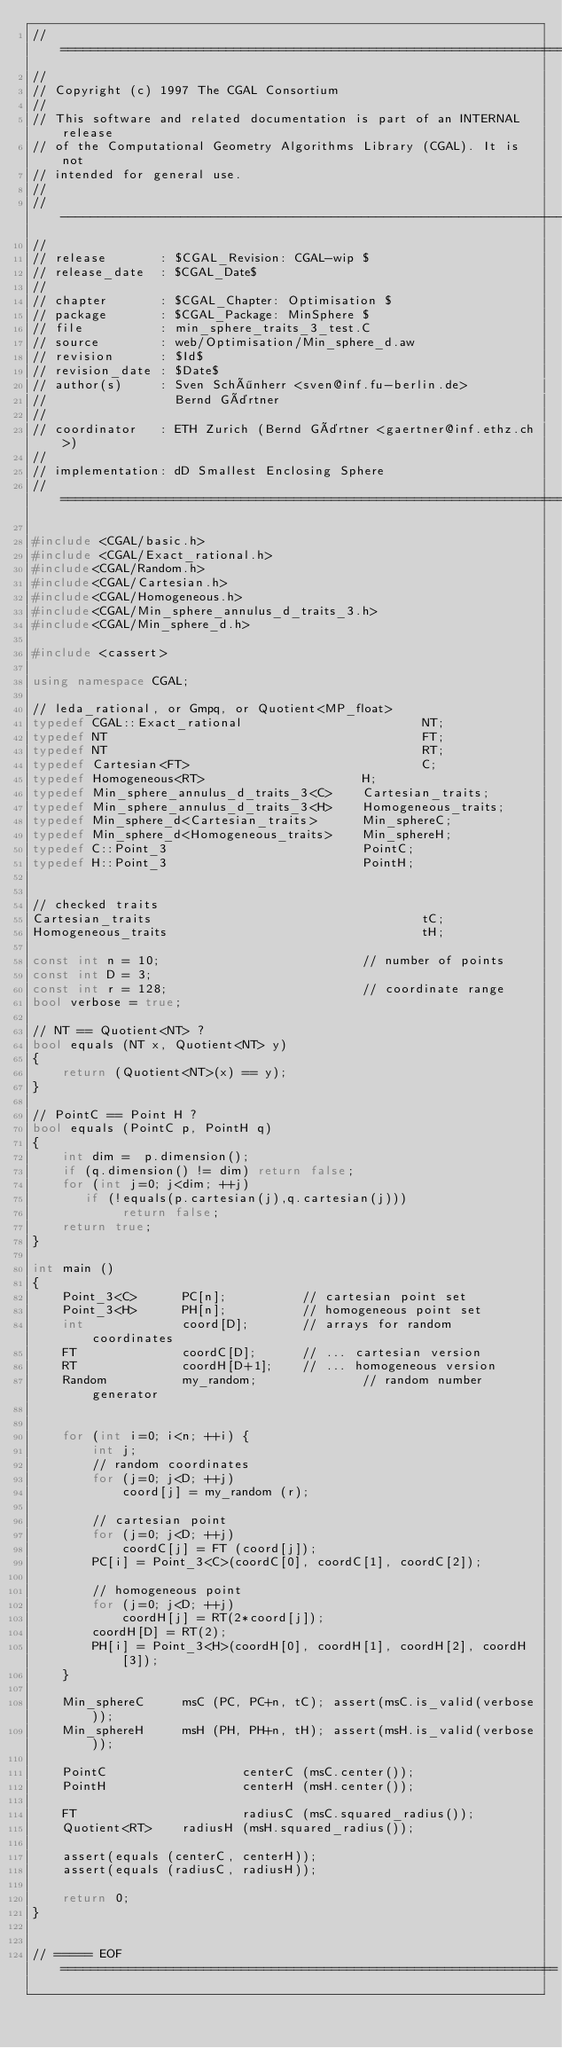Convert code to text. <code><loc_0><loc_0><loc_500><loc_500><_C++_>// ============================================================================
//
// Copyright (c) 1997 The CGAL Consortium
//
// This software and related documentation is part of an INTERNAL release
// of the Computational Geometry Algorithms Library (CGAL). It is not
// intended for general use.
//
// ----------------------------------------------------------------------------
//
// release       : $CGAL_Revision: CGAL-wip $
// release_date  : $CGAL_Date$
//
// chapter       : $CGAL_Chapter: Optimisation $
// package       : $CGAL_Package: MinSphere $
// file          : min_sphere_traits_3_test.C
// source        : web/Optimisation/Min_sphere_d.aw
// revision      : $Id$
// revision_date : $Date$
// author(s)     : Sven Schönherr <sven@inf.fu-berlin.de>
//                 Bernd Gärtner
//
// coordinator   : ETH Zurich (Bernd Gärtner <gaertner@inf.ethz.ch>)
//
// implementation: dD Smallest Enclosing Sphere
// ============================================================================

#include <CGAL/basic.h>
#include <CGAL/Exact_rational.h>
#include<CGAL/Random.h>
#include<CGAL/Cartesian.h>
#include<CGAL/Homogeneous.h>
#include<CGAL/Min_sphere_annulus_d_traits_3.h>
#include<CGAL/Min_sphere_d.h>

#include <cassert>

using namespace CGAL;

// leda_rational, or Gmpq, or Quotient<MP_float>
typedef CGAL::Exact_rational                        NT;
typedef NT                                          FT;
typedef NT                                          RT;
typedef Cartesian<FT>                               C;
typedef Homogeneous<RT>                     H;
typedef Min_sphere_annulus_d_traits_3<C>    Cartesian_traits;
typedef Min_sphere_annulus_d_traits_3<H>    Homogeneous_traits;
typedef Min_sphere_d<Cartesian_traits>      Min_sphereC;
typedef Min_sphere_d<Homogeneous_traits>    Min_sphereH;
typedef C::Point_3                          PointC;
typedef H::Point_3                          PointH;


// checked traits
Cartesian_traits                                    tC;
Homogeneous_traits                                  tH;

const int n = 10;                           // number of points
const int D = 3;
const int r = 128;                          // coordinate range
bool verbose = true;

// NT == Quotient<NT> ?
bool equals (NT x, Quotient<NT> y)
{
    return (Quotient<NT>(x) == y);
}

// PointC == Point H ?
bool equals (PointC p, PointH q)
{
    int dim =  p.dimension();
    if (q.dimension() != dim) return false;
    for (int j=0; j<dim; ++j)
       if (!equals(p.cartesian(j),q.cartesian(j)))
            return false;
    return true;
}

int main ()
{
    Point_3<C>      PC[n];          // cartesian point set
    Point_3<H>      PH[n];          // homogeneous point set
    int             coord[D];       // arrays for random coordinates
    FT              coordC[D];      // ... cartesian version
    RT              coordH[D+1];    // ... homogeneous version
    Random          my_random;              // random number generator


    for (int i=0; i<n; ++i) {
        int j;
        // random coordinates
        for (j=0; j<D; ++j)
            coord[j] = my_random (r);

        // cartesian point
        for (j=0; j<D; ++j)
            coordC[j] = FT (coord[j]);
        PC[i] = Point_3<C>(coordC[0], coordC[1], coordC[2]);

        // homogeneous point
        for (j=0; j<D; ++j)
            coordH[j] = RT(2*coord[j]);
        coordH[D] = RT(2);
        PH[i] = Point_3<H>(coordH[0], coordH[1], coordH[2], coordH[3]);
    }

    Min_sphereC     msC (PC, PC+n, tC); assert(msC.is_valid(verbose));
    Min_sphereH     msH (PH, PH+n, tH); assert(msH.is_valid(verbose));

    PointC                  centerC (msC.center());
    PointH                  centerH (msH.center());

    FT                      radiusC (msC.squared_radius());
    Quotient<RT>    radiusH (msH.squared_radius());

    assert(equals (centerC, centerH));
    assert(equals (radiusC, radiusH));

    return 0;
}


// ===== EOF ==================================================================

</code> 